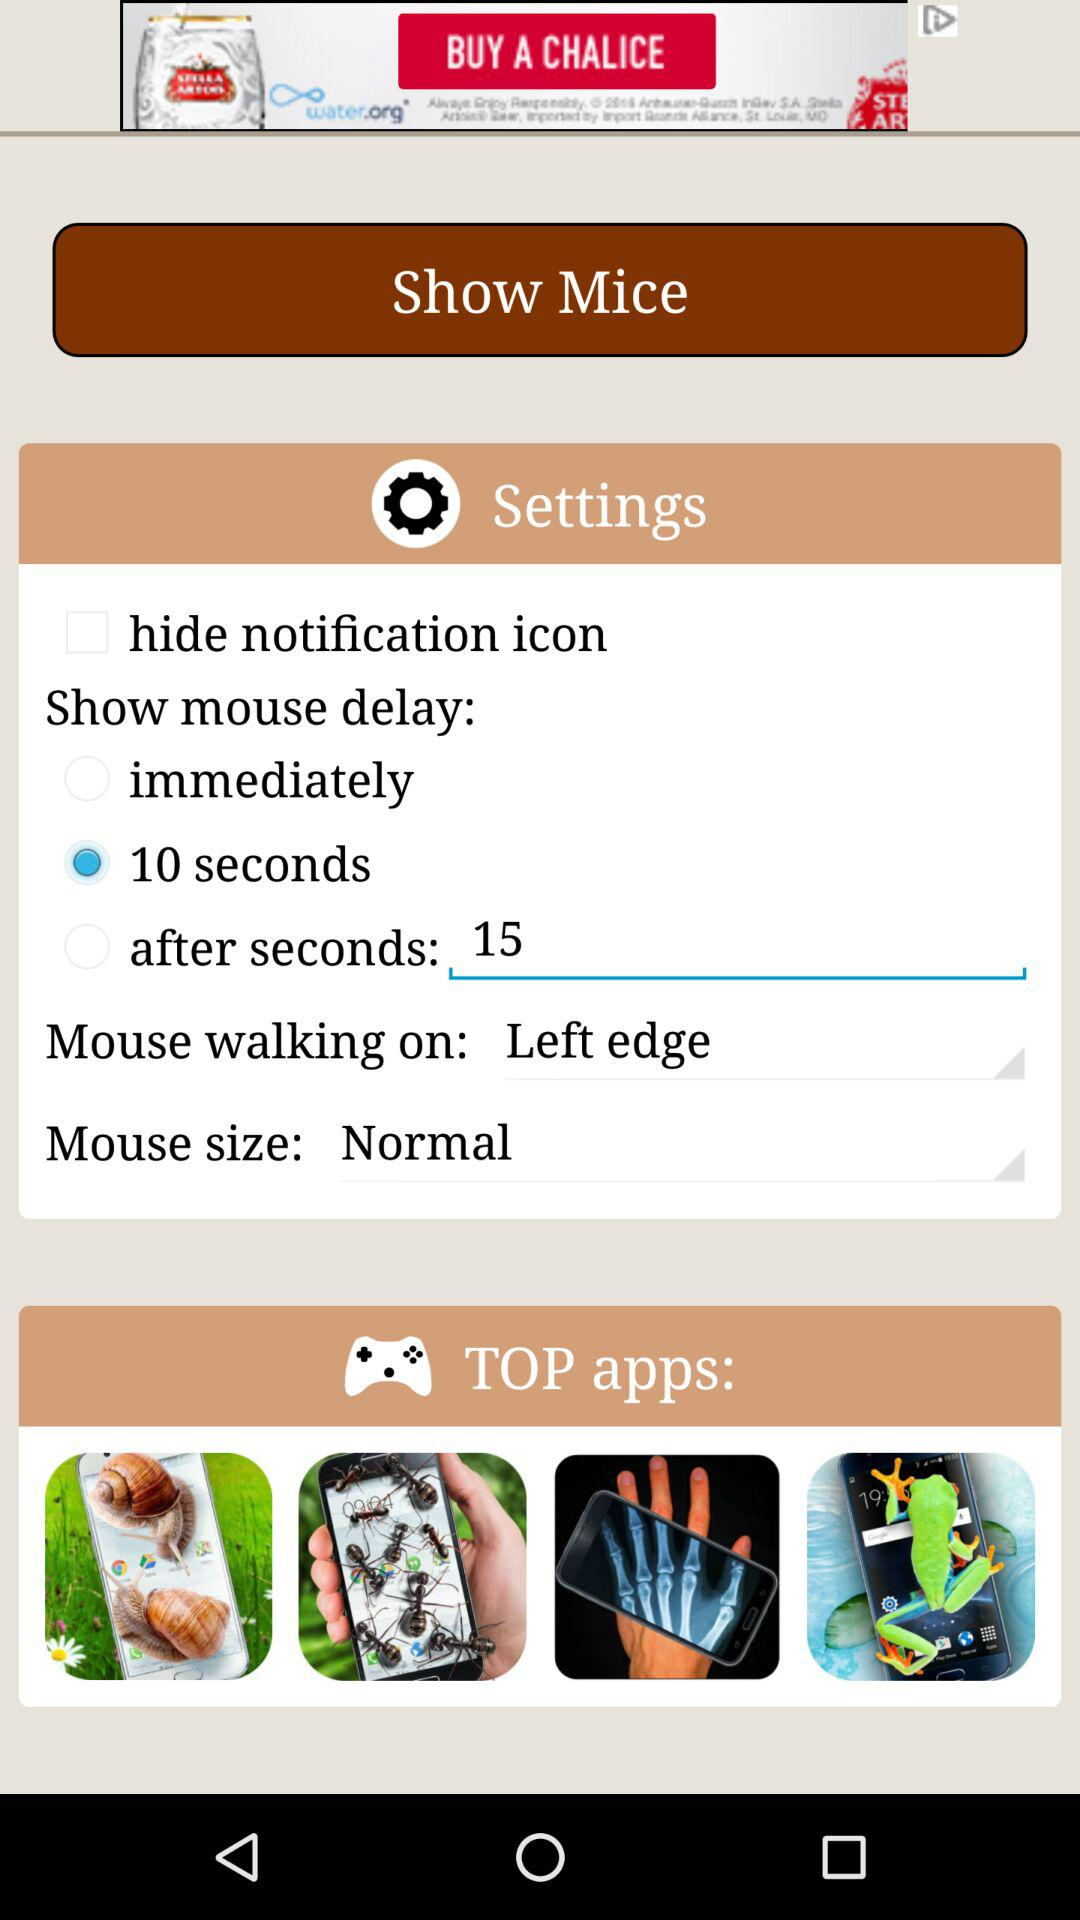Which option is selected for the "Mouse walking on"? The selected option for "Mouse walking on" is "Left edge". 